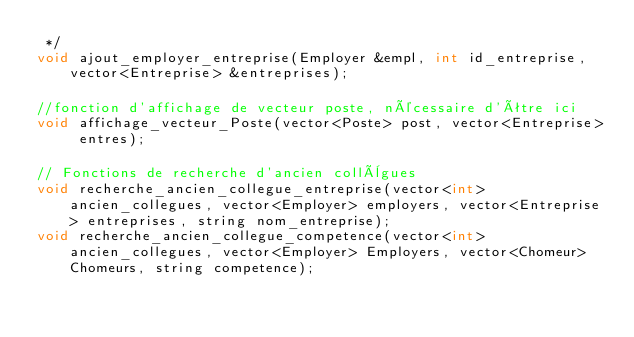<code> <loc_0><loc_0><loc_500><loc_500><_C_> */
void ajout_employer_entreprise(Employer &empl, int id_entreprise, vector<Entreprise> &entreprises);

//fonction d'affichage de vecteur poste, nécessaire d'être ici
void affichage_vecteur_Poste(vector<Poste> post, vector<Entreprise> entres);

// Fonctions de recherche d'ancien collègues
void recherche_ancien_collegue_entreprise(vector<int> ancien_collegues, vector<Employer> employers, vector<Entreprise> entreprises, string nom_entreprise);
void recherche_ancien_collegue_competence(vector<int> ancien_collegues, vector<Employer> Employers, vector<Chomeur> Chomeurs, string competence);
</code> 